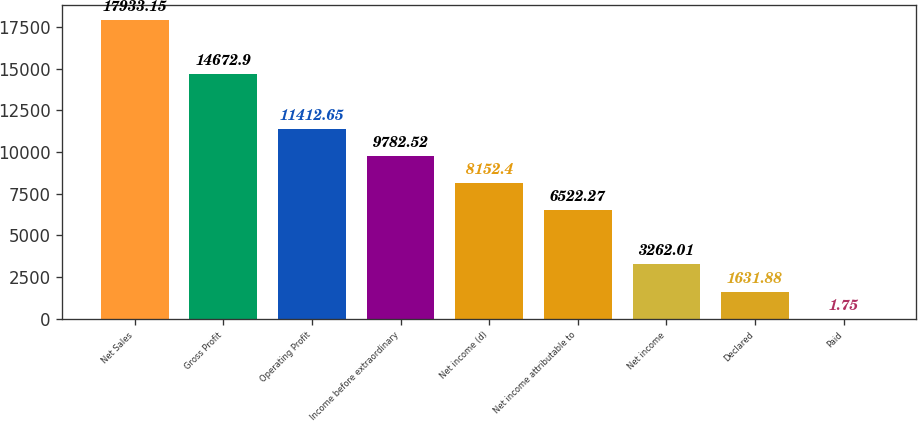<chart> <loc_0><loc_0><loc_500><loc_500><bar_chart><fcel>Net Sales<fcel>Gross Profit<fcel>Operating Profit<fcel>Income before extraordinary<fcel>Net income (d)<fcel>Net income attributable to<fcel>Net income<fcel>Declared<fcel>Paid<nl><fcel>17933.2<fcel>14672.9<fcel>11412.6<fcel>9782.52<fcel>8152.4<fcel>6522.27<fcel>3262.01<fcel>1631.88<fcel>1.75<nl></chart> 